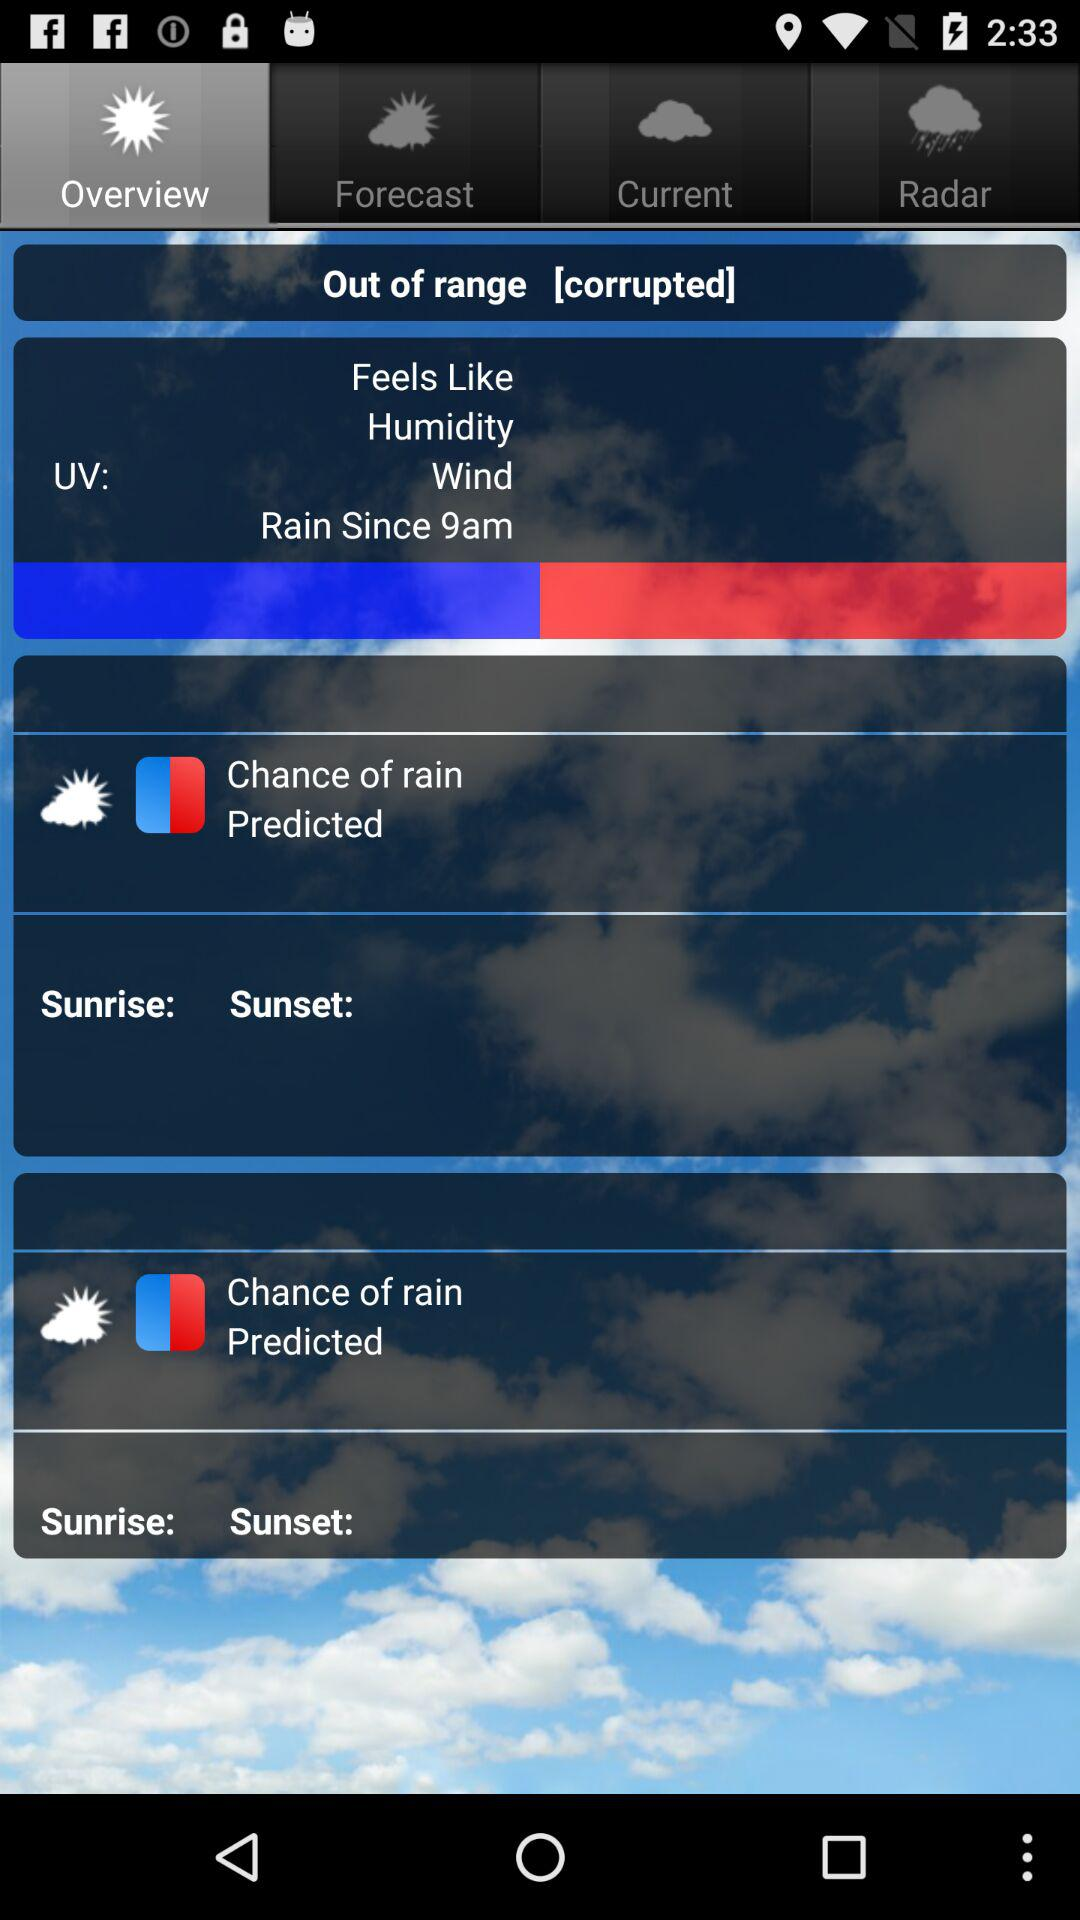At what time will the rain start? The rain will start at 9 a.m. 